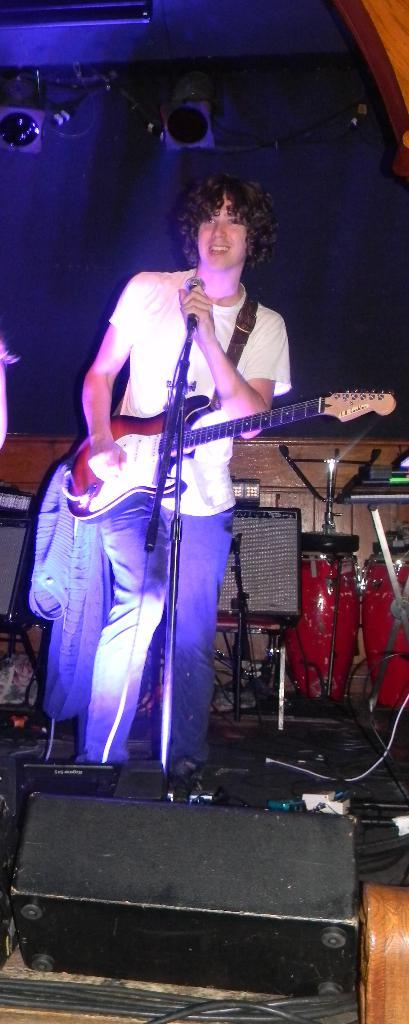What is the man in the image doing? The man is playing the guitar and singing into a microphone. What instrument is the man holding in the image? The man is holding a guitar in the image. What can be seen in the background of the image? There is a wall in the image. What other musical instrument is visible in the image? There are drums in the image. What type of material is present in the image? There is a cloth in the image. What type of noise can be heard coming from the design in the image? There is no design present in the image, and therefore no noise can be heard from it. 